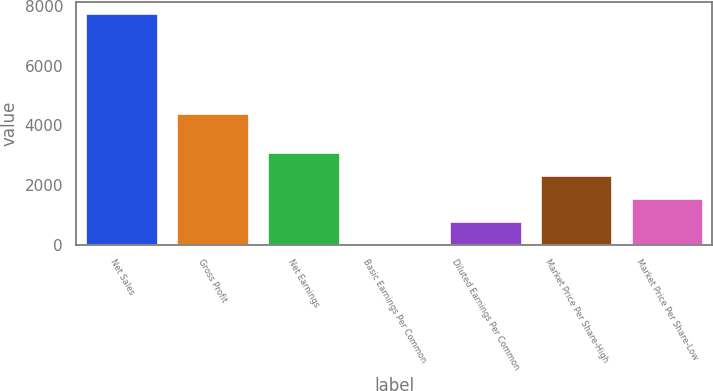<chart> <loc_0><loc_0><loc_500><loc_500><bar_chart><fcel>Net Sales<fcel>Gross Profit<fcel>Net Earnings<fcel>Basic Earnings Per Common<fcel>Diluted Earnings Per Common<fcel>Market Price Per Share-High<fcel>Market Price Per Share-Low<nl><fcel>7761.3<fcel>4401.2<fcel>3105.11<fcel>0.95<fcel>776.99<fcel>2329.07<fcel>1553.03<nl></chart> 